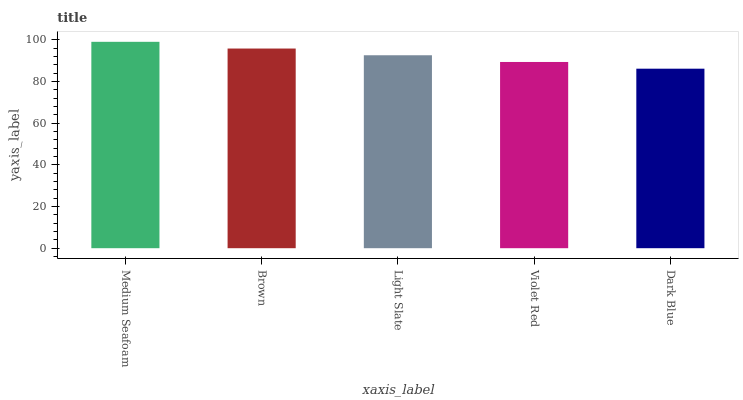Is Dark Blue the minimum?
Answer yes or no. Yes. Is Medium Seafoam the maximum?
Answer yes or no. Yes. Is Brown the minimum?
Answer yes or no. No. Is Brown the maximum?
Answer yes or no. No. Is Medium Seafoam greater than Brown?
Answer yes or no. Yes. Is Brown less than Medium Seafoam?
Answer yes or no. Yes. Is Brown greater than Medium Seafoam?
Answer yes or no. No. Is Medium Seafoam less than Brown?
Answer yes or no. No. Is Light Slate the high median?
Answer yes or no. Yes. Is Light Slate the low median?
Answer yes or no. Yes. Is Brown the high median?
Answer yes or no. No. Is Medium Seafoam the low median?
Answer yes or no. No. 